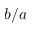Convert formula to latex. <formula><loc_0><loc_0><loc_500><loc_500>b / a</formula> 